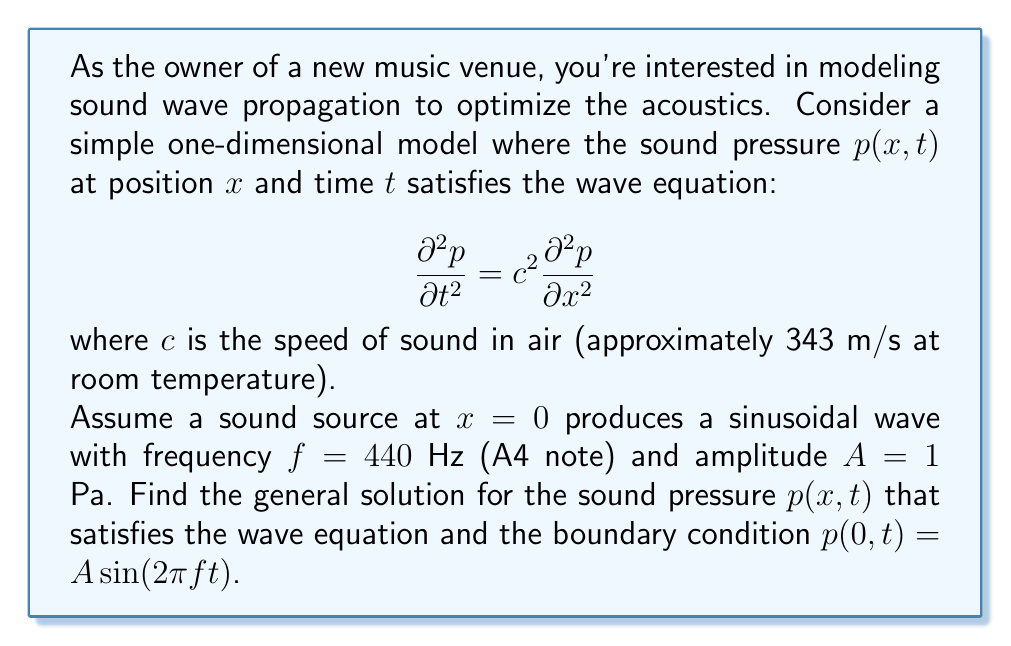Show me your answer to this math problem. Let's solve this step-by-step:

1) The general solution to the wave equation is of the form:
   $$p(x,t) = F(x-ct) + G(x+ct)$$
   where $F$ and $G$ are arbitrary functions.

2) For a sinusoidal wave traveling in the positive x-direction, we can write:
   $$p(x,t) = A\sin(kx - \omega t)$$
   where $k$ is the wave number and $\omega$ is the angular frequency.

3) We know that $\omega = 2\pi f$ and $k = \omega/c = 2\pi f/c$.

4) Substituting the given values:
   $f = 440$ Hz
   $c = 343$ m/s
   $A = 1$ Pa

5) Calculate $k$:
   $$k = \frac{2\pi f}{c} = \frac{2\pi(440)}{343} \approx 8.05 \text{ m}^{-1}$$

6) The general solution that satisfies the boundary condition is:
   $$p(x,t) = A\sin(kx - \omega t) = \sin(8.05x - 2\pi(440)t)$$

This represents a wave traveling in the positive x-direction with wavelength $\lambda = 2\pi/k \approx 0.78$ m.
Answer: $p(x,t) = \sin(8.05x - 2\pi(440)t)$ Pa 